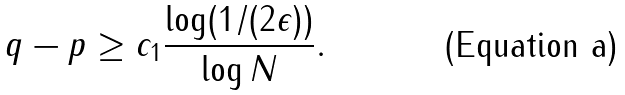Convert formula to latex. <formula><loc_0><loc_0><loc_500><loc_500>q - p \geq c _ { 1 } \frac { \log ( 1 / ( 2 \epsilon ) ) } { \log N } .</formula> 